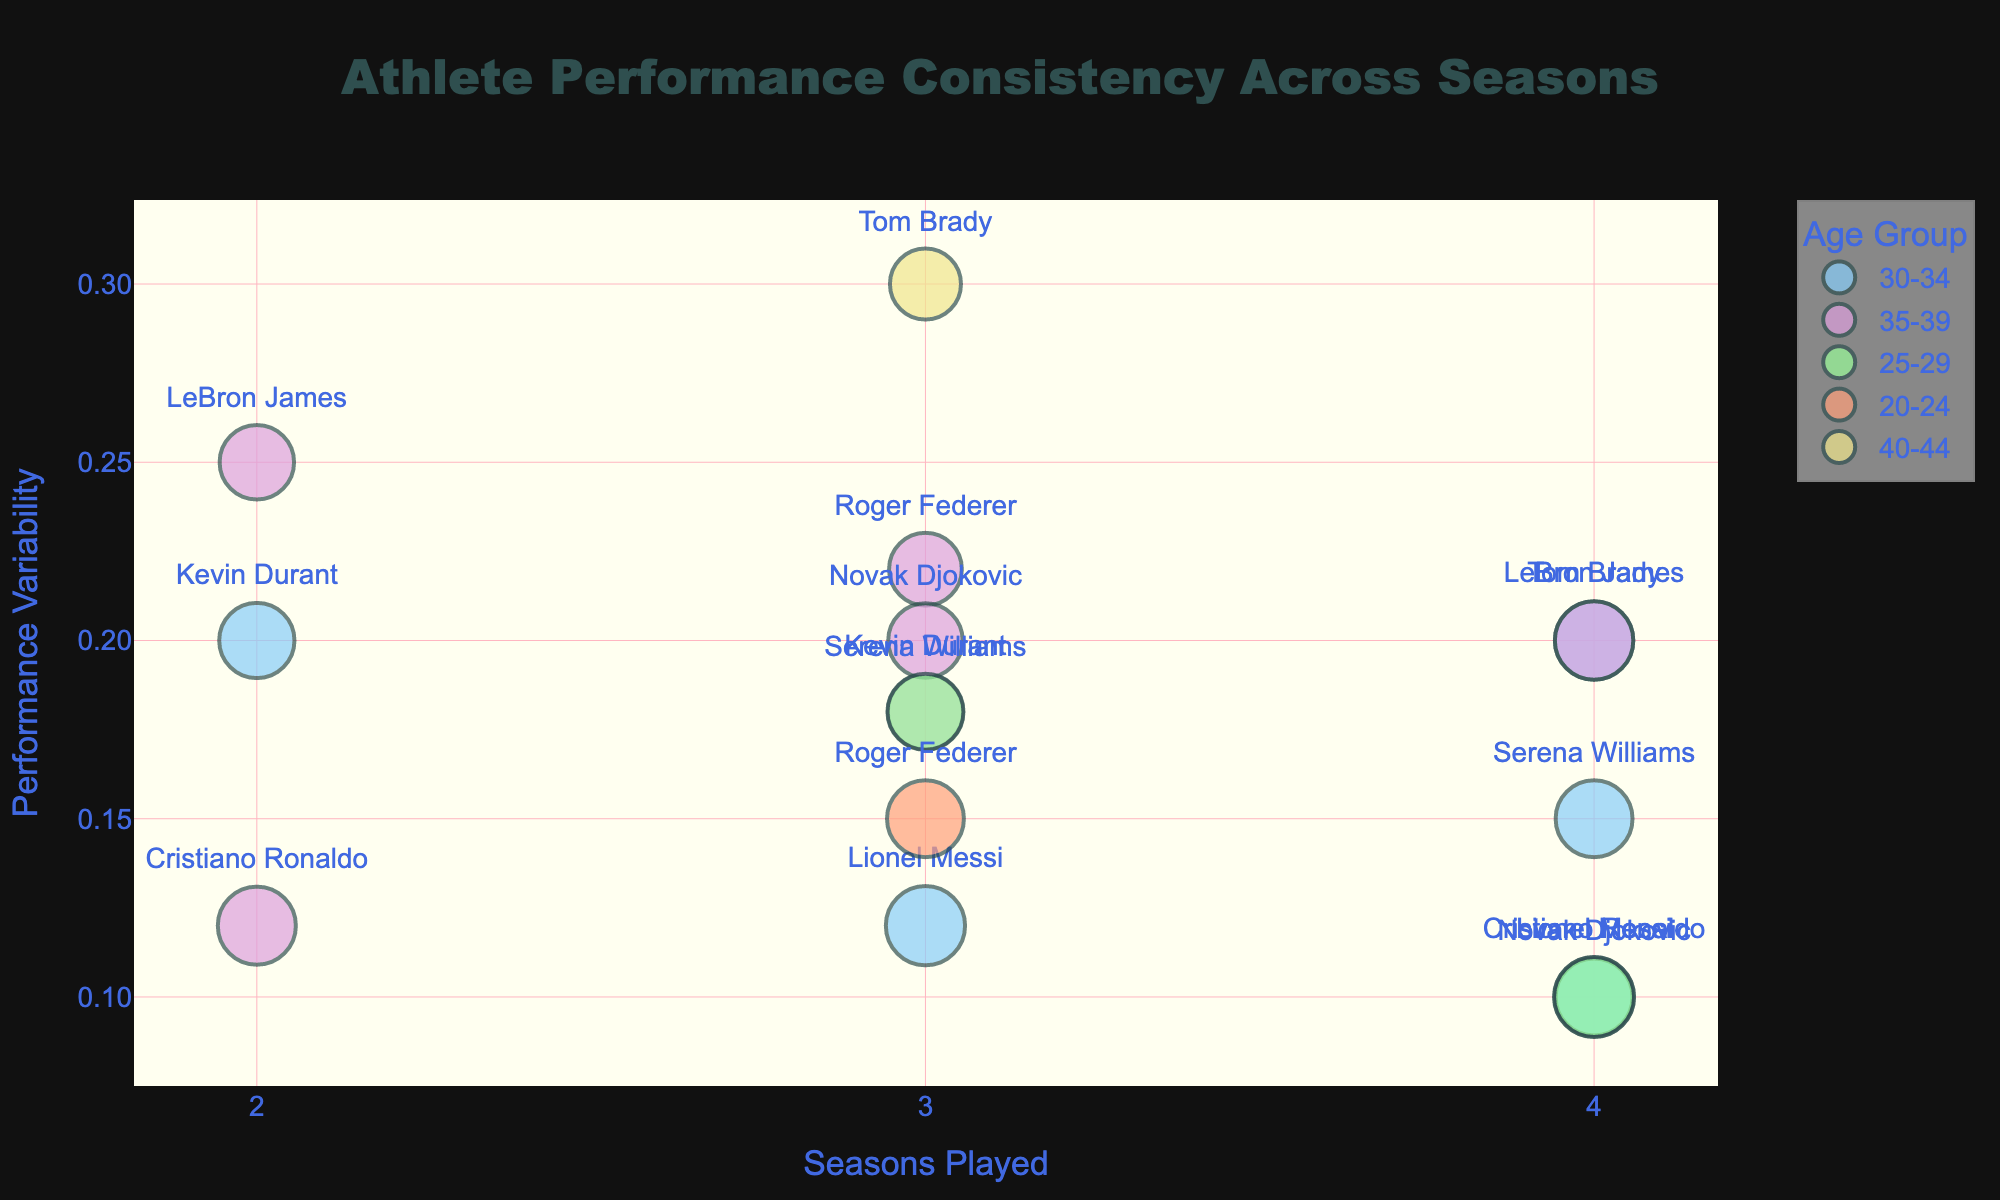What is the title of the bubble chart? The title appears at the top of the figure, centered and in a larger font, "Athlete Performance Consistency Across Seasons".
Answer: Athlete Performance Consistency Across Seasons How is Performance Variability represented in the bubble chart? Performance Variability is represented on the y-axis of the chart, which allows us to see the range of variability for different athletes across seasons.
Answer: y-axis Which Age Group has the largest bubble for Cristiano Ronaldo? Find the bubbles labeled "Cristiano Ronaldo" and compare their sizes. The largest bubble size for Cristiano Ronaldo is 515 in the 30-34 age group.
Answer: 30-34 Which athlete has the lowest Performance Variability and in which age group? Look for the bubble at the lowest point on the y-axis (closest to 0) and identify the athlete and their age group. Lionel Messi in the 25-29 age group has the lowest performance variability of 0.1.
Answer: Lionel Messi, 25-29 What is the average Seasons Played by athletes in the 35-39 age group? Calculate the average by adding the number of seasons played by each athlete in the 35-39 age group and dividing by the number of those athletes. (2+3+3+2+3)/5 = 2.6
Answer: 2.6 How does Performance Variability compare between LeBron James in the 30-34 and 35-39 age groups? Compare the y-axis values for LeBron James in both age groups. The variability is 0.2 in the 30-34 age group and 0.25 in the 35-39 age group, which shows an increase in variability as LeBron ages.
Answer: 0.25 is greater than 0.2 How does the bubble size for Tom Brady in the 35-39 age group compare with the bubble size for Tom Brady in the 40-44 age group? Look at the bubbles for Tom Brady and compare their sizes. The bubble size for Tom Brady is larger in the 35-39 age group (500) than in the 40-44 age group (410).
Answer: 500 is greater than 410 Which age group has the highest average Performance Variability? Calculate the average Performance Variability for each age group: 
- 20-24: 0.15 
- 25-29: (0.1+0.18)/2 
- 30-34: (0.2+0.15+0.1+0.2+0.1)/5 
- 35-39: (0.25+0.18+0.22+0.1+0.3+0.2)/6 
- 40-44: 0.3
The highest average is for the 35-39 age group.
Answer: 35-39 Which athlete has played the most seasons within the 30-34 age group? For each bubble in the 30-34 age group, find the athlete with the highest number of seasons played. LeBron James has played 4 seasons.
Answer: LeBron James 